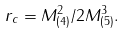<formula> <loc_0><loc_0><loc_500><loc_500>r _ { c } = { M _ { ( 4 ) } ^ { 2 } } / { 2 M _ { ( 5 ) } ^ { 3 } } .</formula> 